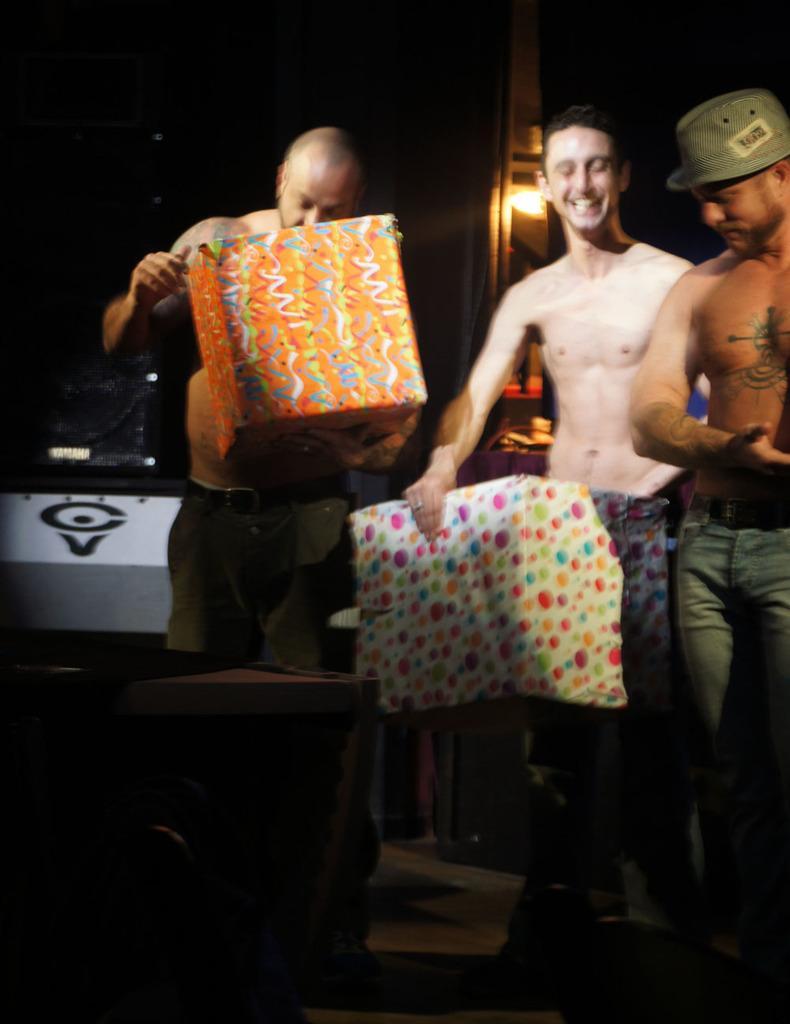Can you describe this image briefly? There are three persons standing as we can see in the middle of this image. The two persons are holding an object and we can see other objects in the background. 